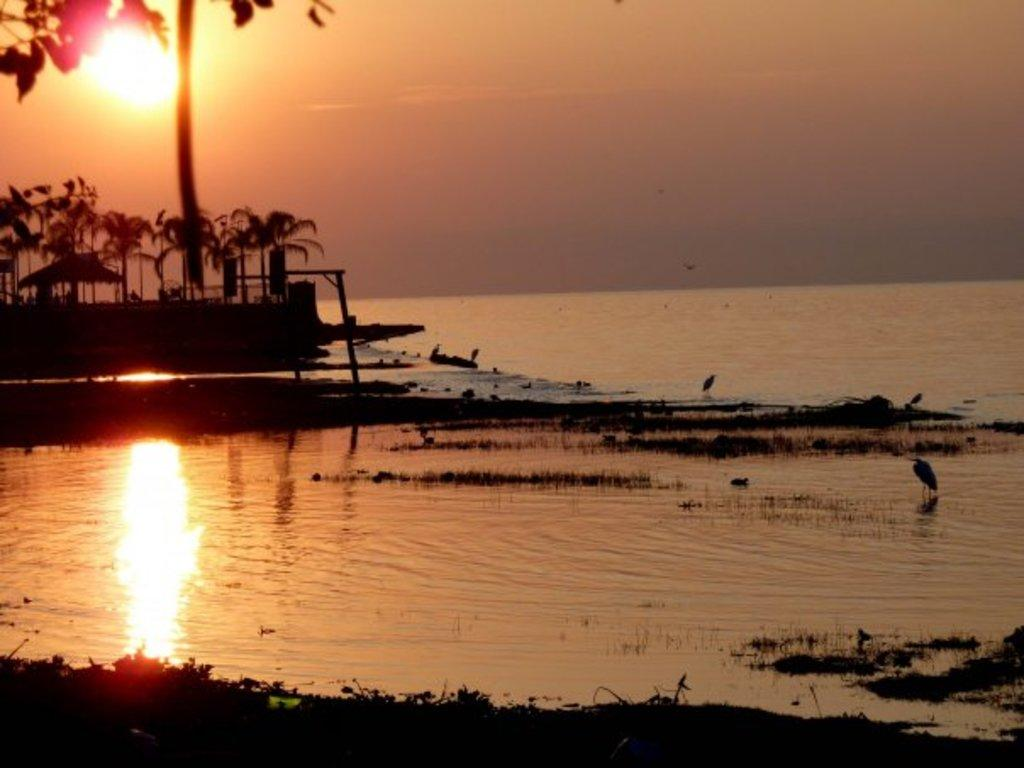What is happening to the sun in the image? The sun is rising in the sky in the image. What can be seen in the middle of the image? There is a lake in the middle of the image. What type of vegetation is on the left side of the image? There are trees on the left side of the image. What type of chalk is being used to draw on the lake in the image? There is no chalk or drawing activity present in the image; it features a rising sun, a lake, and trees. How many boots can be seen floating in the lake in the image? There are no boots present in the image; it features a rising sun, a lake, and trees. 